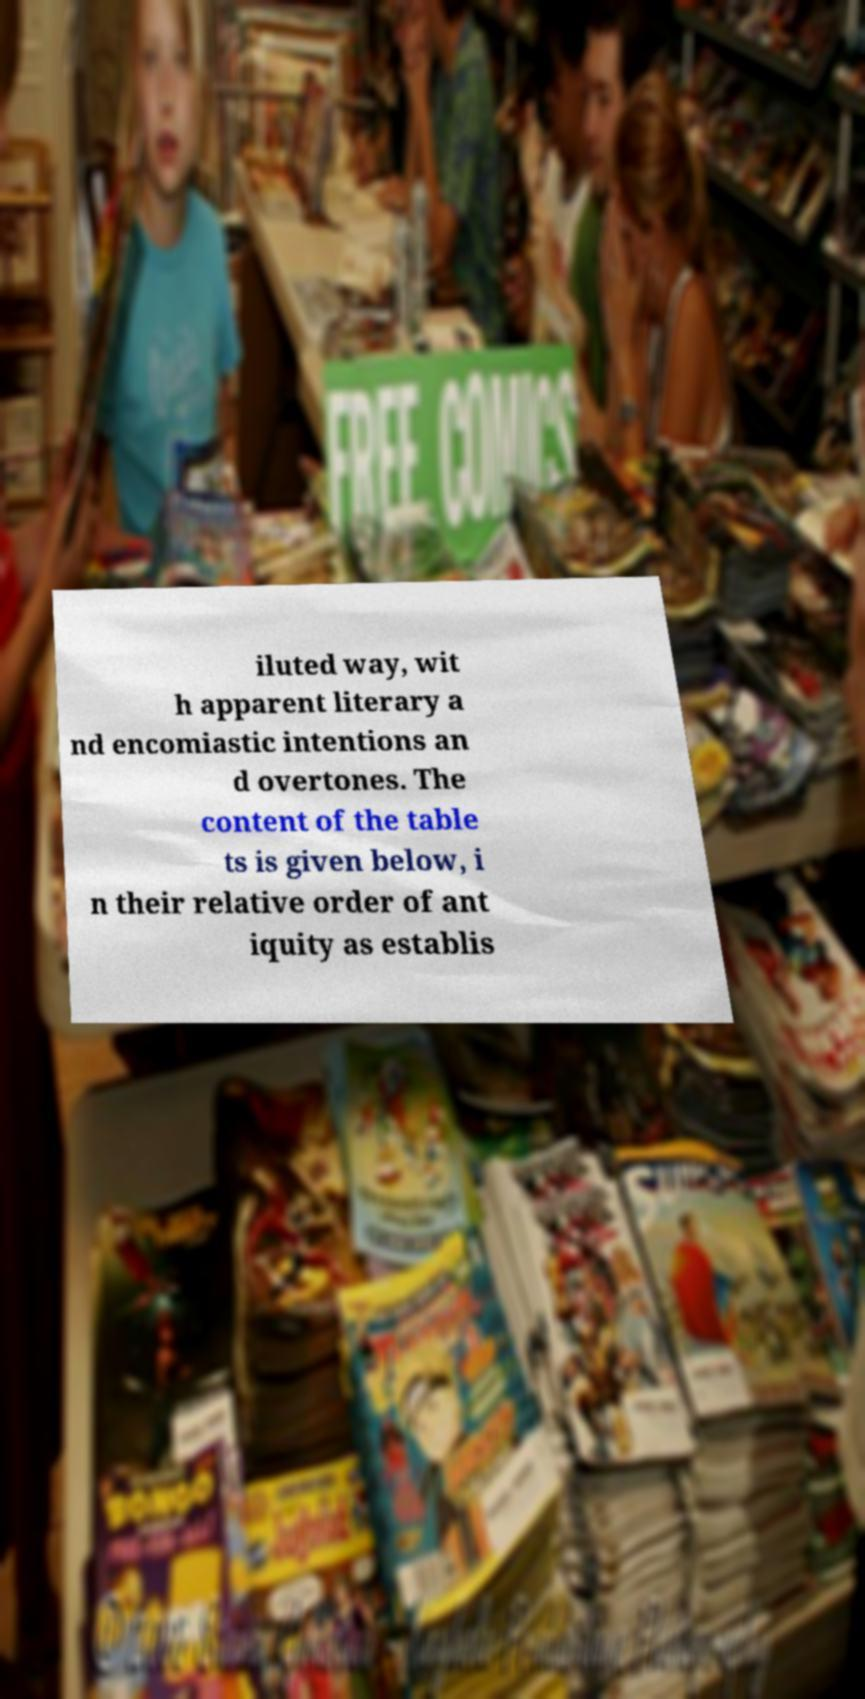What messages or text are displayed in this image? I need them in a readable, typed format. iluted way, wit h apparent literary a nd encomiastic intentions an d overtones. The content of the table ts is given below, i n their relative order of ant iquity as establis 